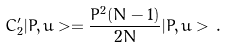Convert formula to latex. <formula><loc_0><loc_0><loc_500><loc_500>C ^ { \prime } _ { 2 } | P , u > = \frac { P ^ { 2 } ( N - 1 ) } { 2 N } | P , u > \, .</formula> 